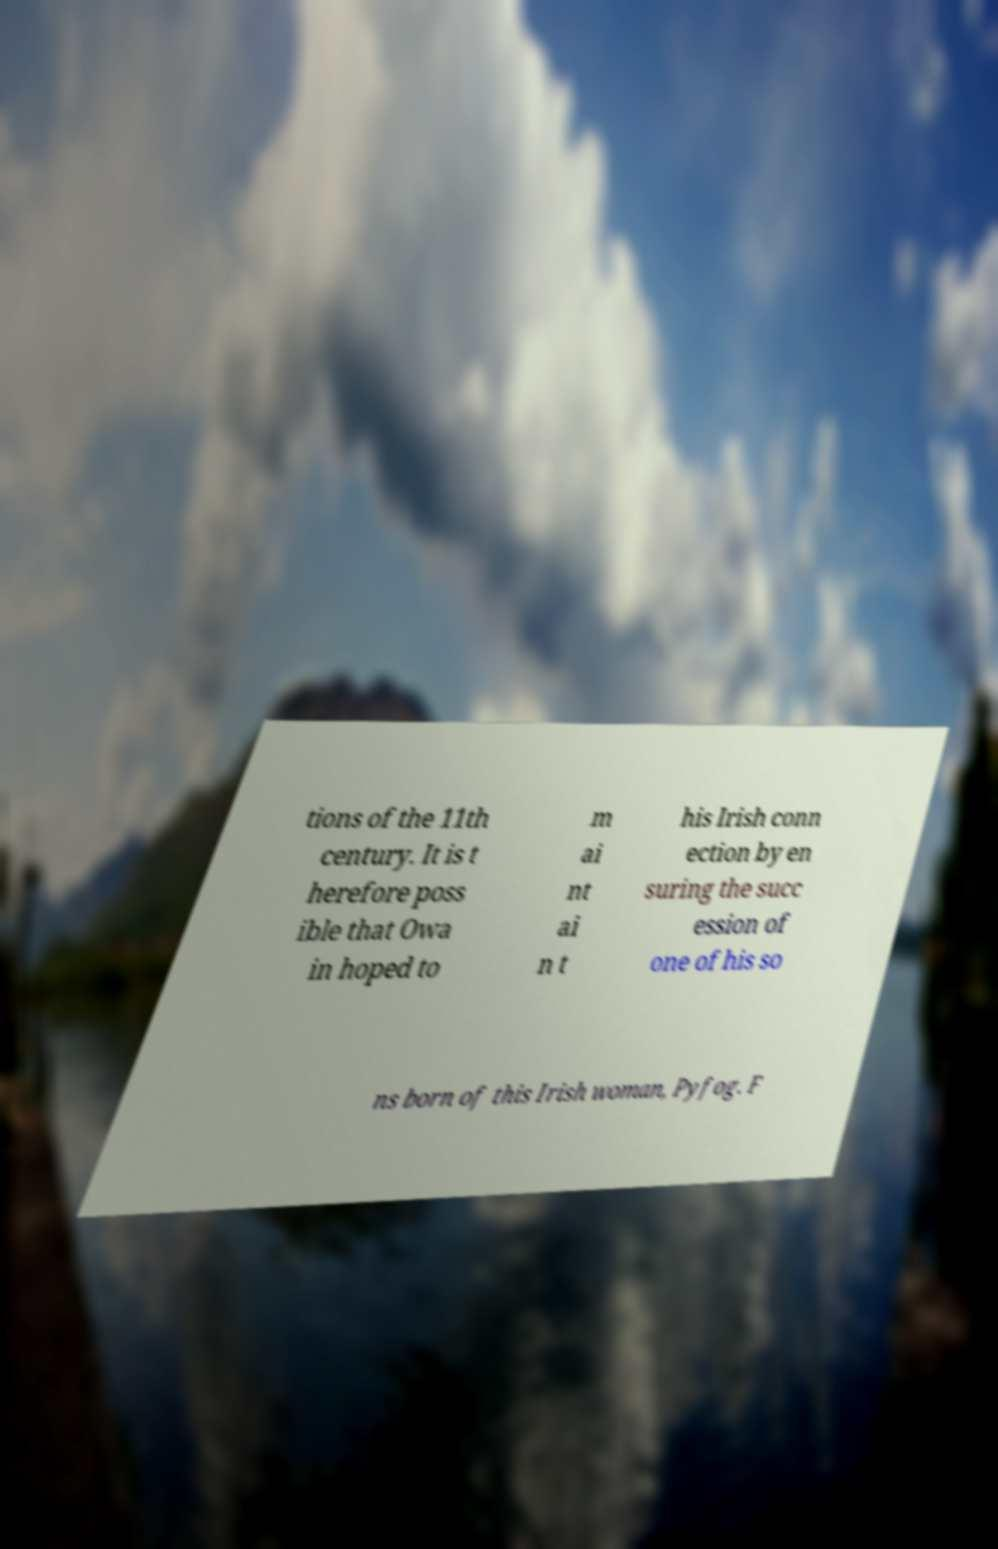Can you accurately transcribe the text from the provided image for me? tions of the 11th century. It is t herefore poss ible that Owa in hoped to m ai nt ai n t his Irish conn ection by en suring the succ ession of one of his so ns born of this Irish woman, Pyfog. F 